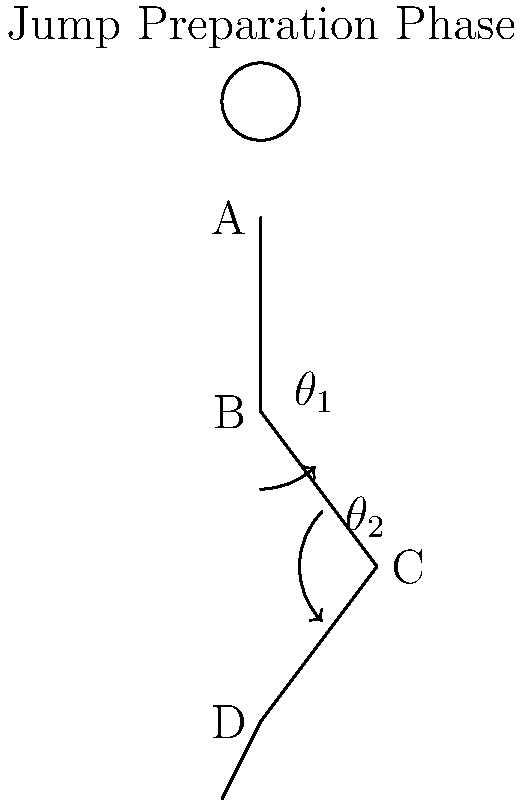In the jump preparation phase shown in the video still, calculate the knee angle ($\theta_2$) if the hip angle ($\theta_1$) is 45° and the angle between the thigh and the vertical axis is 30°. To calculate the knee angle ($\theta_2$), we'll follow these steps:

1. Identify the relevant angles:
   - Hip angle ($\theta_1$) = 45°
   - Angle between thigh and vertical = 30°

2. Understand the relationship between angles:
   - The knee angle ($\theta_2$) is supplementary to the sum of the hip angle and the thigh-vertical angle.

3. Calculate the sum of the known angles:
   $45° + 30° = 75°$

4. Use the supplementary angle relationship:
   Supplementary angles add up to 180°
   $\theta_2 + 75° = 180°$

5. Solve for $\theta_2$:
   $\theta_2 = 180° - 75° = 105°$

Therefore, the knee angle ($\theta_2$) is 105°.
Answer: 105° 